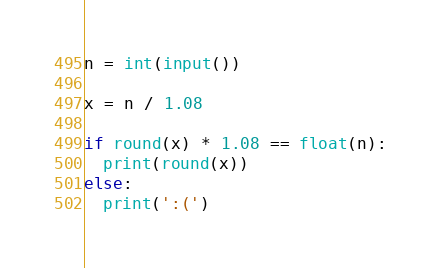<code> <loc_0><loc_0><loc_500><loc_500><_Python_>n = int(input())

x = n / 1.08

if round(x) * 1.08 == float(n):
  print(round(x))
else:
  print(':(')
</code> 